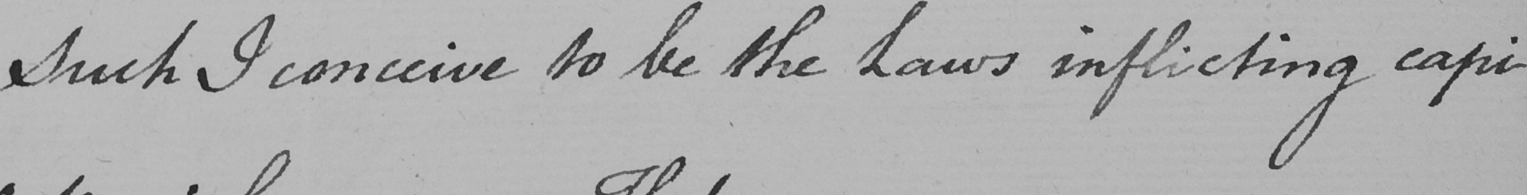What does this handwritten line say? Such I conceive to be the Laws inflicting capi- 